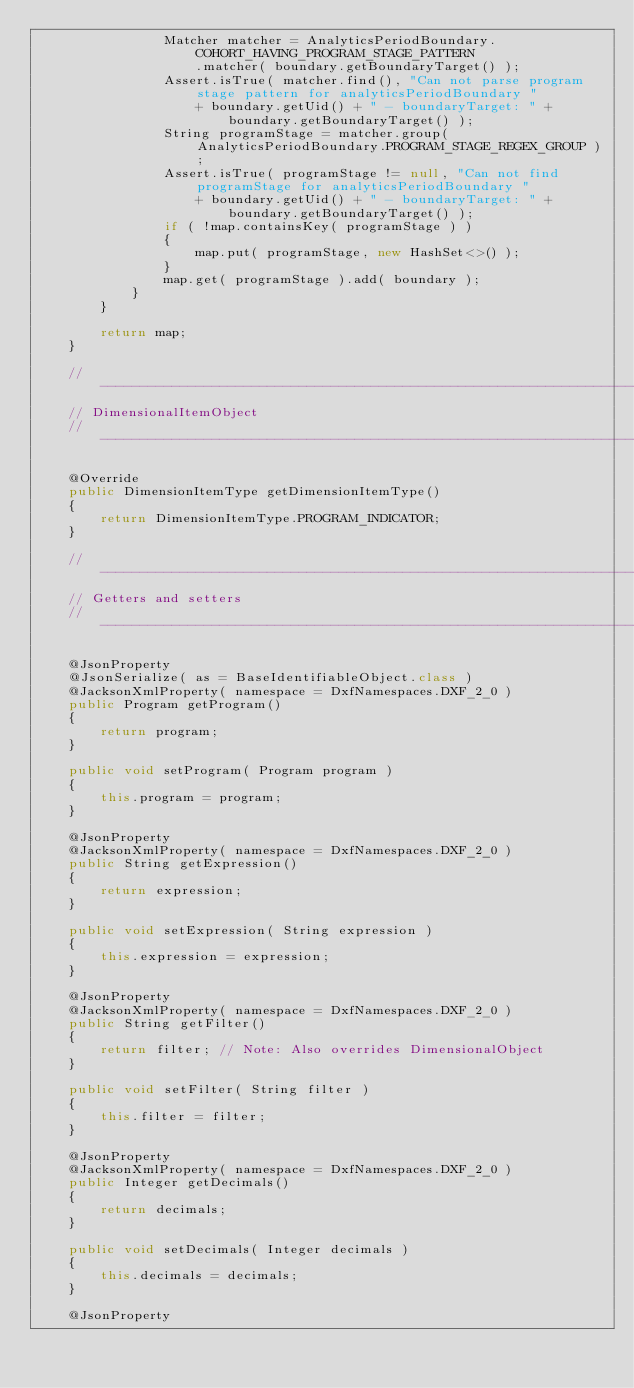Convert code to text. <code><loc_0><loc_0><loc_500><loc_500><_Java_>                Matcher matcher = AnalyticsPeriodBoundary.COHORT_HAVING_PROGRAM_STAGE_PATTERN
                    .matcher( boundary.getBoundaryTarget() );
                Assert.isTrue( matcher.find(), "Can not parse program stage pattern for analyticsPeriodBoundary "
                    + boundary.getUid() + " - boundaryTarget: " + boundary.getBoundaryTarget() );
                String programStage = matcher.group( AnalyticsPeriodBoundary.PROGRAM_STAGE_REGEX_GROUP );
                Assert.isTrue( programStage != null, "Can not find programStage for analyticsPeriodBoundary "
                    + boundary.getUid() + " - boundaryTarget: " + boundary.getBoundaryTarget() );
                if ( !map.containsKey( programStage ) )
                {
                    map.put( programStage, new HashSet<>() );
                }
                map.get( programStage ).add( boundary );
            }
        }

        return map;
    }

    // -------------------------------------------------------------------------
    // DimensionalItemObject
    // -------------------------------------------------------------------------

    @Override
    public DimensionItemType getDimensionItemType()
    {
        return DimensionItemType.PROGRAM_INDICATOR;
    }

    // -------------------------------------------------------------------------
    // Getters and setters
    // -------------------------------------------------------------------------

    @JsonProperty
    @JsonSerialize( as = BaseIdentifiableObject.class )
    @JacksonXmlProperty( namespace = DxfNamespaces.DXF_2_0 )
    public Program getProgram()
    {
        return program;
    }

    public void setProgram( Program program )
    {
        this.program = program;
    }

    @JsonProperty
    @JacksonXmlProperty( namespace = DxfNamespaces.DXF_2_0 )
    public String getExpression()
    {
        return expression;
    }

    public void setExpression( String expression )
    {
        this.expression = expression;
    }

    @JsonProperty
    @JacksonXmlProperty( namespace = DxfNamespaces.DXF_2_0 )
    public String getFilter()
    {
        return filter; // Note: Also overrides DimensionalObject
    }

    public void setFilter( String filter )
    {
        this.filter = filter;
    }

    @JsonProperty
    @JacksonXmlProperty( namespace = DxfNamespaces.DXF_2_0 )
    public Integer getDecimals()
    {
        return decimals;
    }

    public void setDecimals( Integer decimals )
    {
        this.decimals = decimals;
    }

    @JsonProperty</code> 